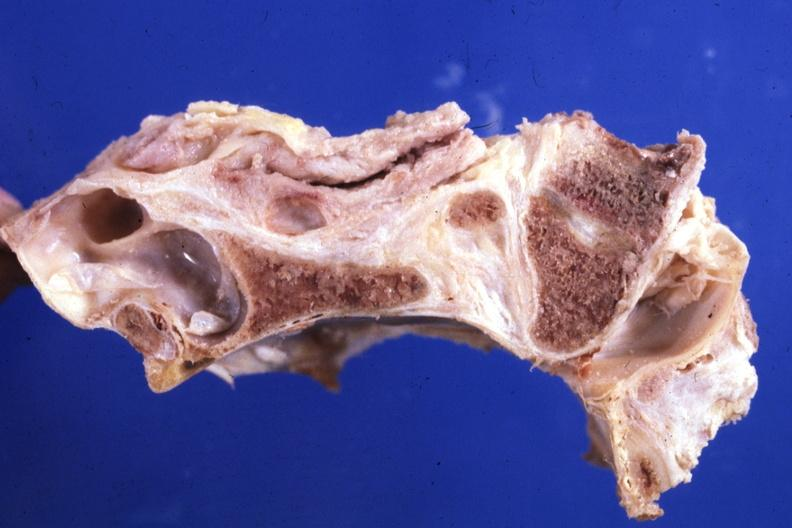s intestine present?
Answer the question using a single word or phrase. No 